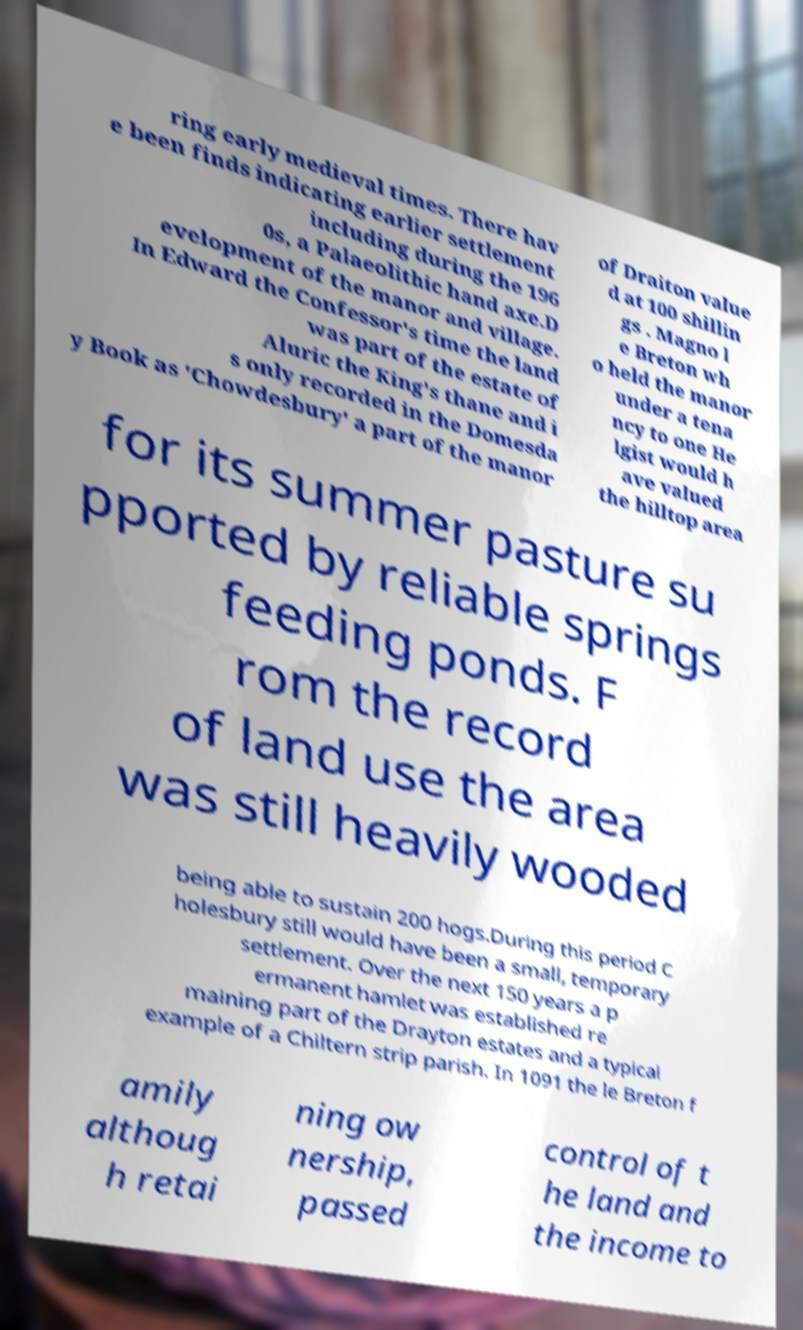For documentation purposes, I need the text within this image transcribed. Could you provide that? ring early medieval times. There hav e been finds indicating earlier settlement including during the 196 0s, a Palaeolithic hand axe.D evelopment of the manor and village. In Edward the Confessor's time the land was part of the estate of Aluric the King's thane and i s only recorded in the Domesda y Book as 'Chowdesbury' a part of the manor of Draiton value d at 100 shillin gs . Magno l e Breton wh o held the manor under a tena ncy to one He lgist would h ave valued the hilltop area for its summer pasture su pported by reliable springs feeding ponds. F rom the record of land use the area was still heavily wooded being able to sustain 200 hogs.During this period C holesbury still would have been a small, temporary settlement. Over the next 150 years a p ermanent hamlet was established re maining part of the Drayton estates and a typical example of a Chiltern strip parish. In 1091 the le Breton f amily althoug h retai ning ow nership, passed control of t he land and the income to 